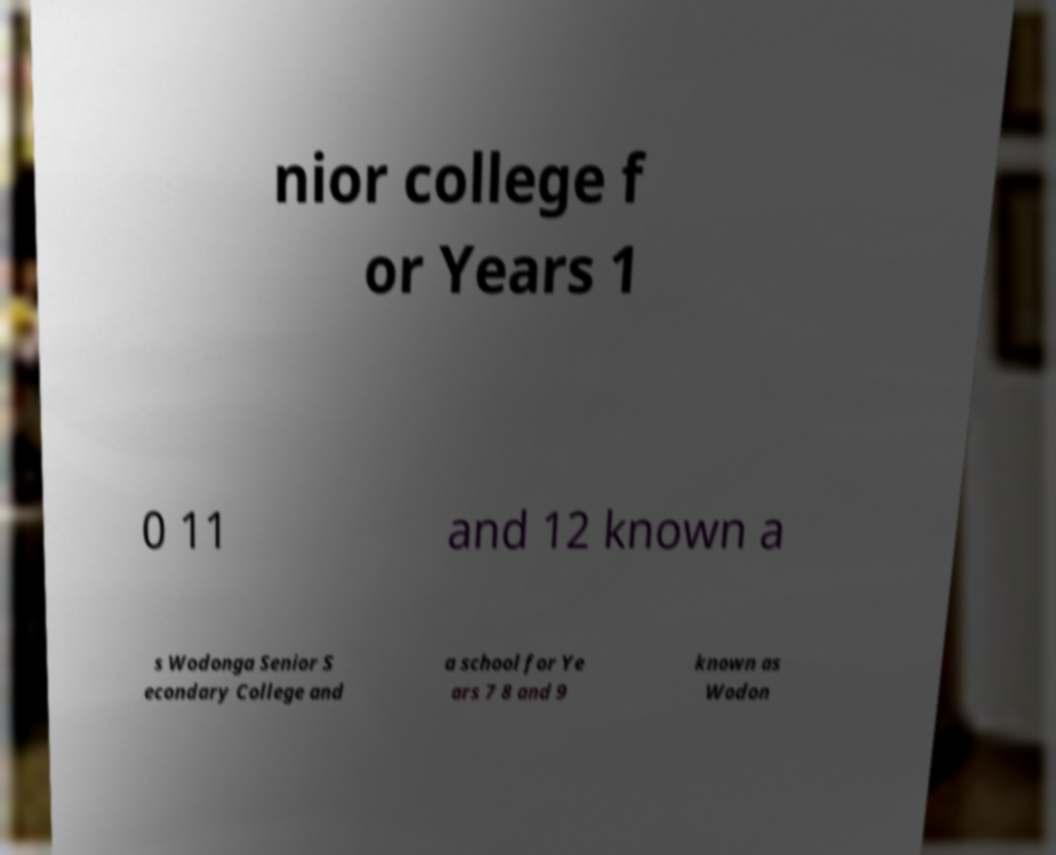Can you read and provide the text displayed in the image?This photo seems to have some interesting text. Can you extract and type it out for me? nior college f or Years 1 0 11 and 12 known a s Wodonga Senior S econdary College and a school for Ye ars 7 8 and 9 known as Wodon 